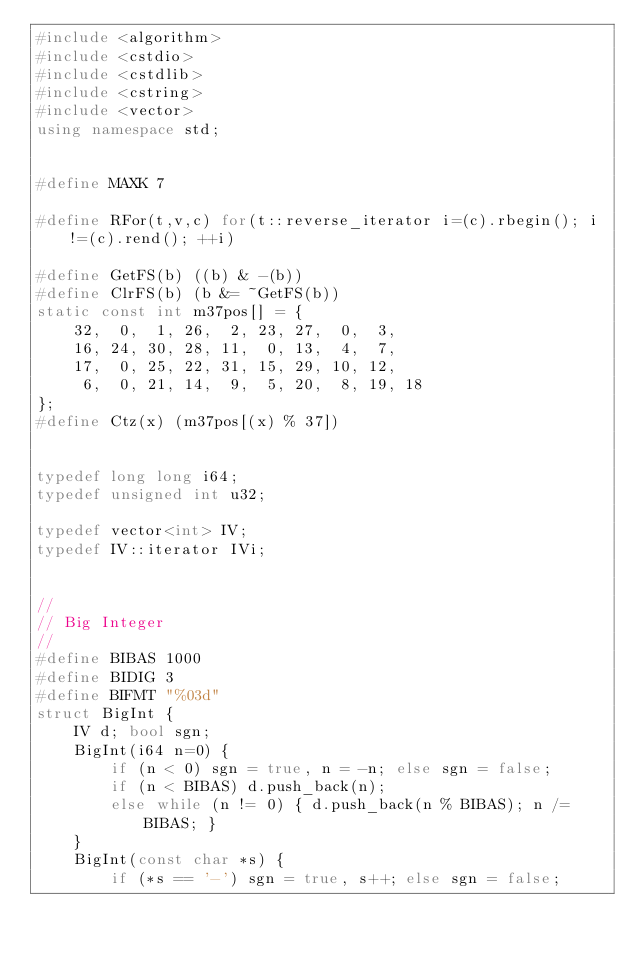<code> <loc_0><loc_0><loc_500><loc_500><_C++_>#include <algorithm>
#include <cstdio>
#include <cstdlib>
#include <cstring>
#include <vector>
using namespace std;


#define MAXK 7

#define RFor(t,v,c) for(t::reverse_iterator i=(c).rbegin(); i!=(c).rend(); ++i)

#define GetFS(b) ((b) & -(b))
#define ClrFS(b) (b &= ~GetFS(b))
static const int m37pos[] = {
    32,  0,  1, 26,  2, 23, 27,  0,  3,
    16, 24, 30, 28, 11,  0, 13,  4,  7,
    17,  0, 25, 22, 31, 15, 29, 10, 12,
     6,  0, 21, 14,  9,  5, 20,  8, 19, 18
};
#define Ctz(x) (m37pos[(x) % 37])


typedef long long i64;
typedef unsigned int u32;

typedef vector<int> IV;
typedef IV::iterator IVi;


//
// Big Integer
//
#define BIBAS 1000
#define BIDIG 3
#define BIFMT "%03d"
struct BigInt {
    IV d; bool sgn;
    BigInt(i64 n=0) {
        if (n < 0) sgn = true, n = -n; else sgn = false;
        if (n < BIBAS) d.push_back(n);
        else while (n != 0) { d.push_back(n % BIBAS); n /= BIBAS; }
    }
    BigInt(const char *s) {
        if (*s == '-') sgn = true, s++; else sgn = false;</code> 